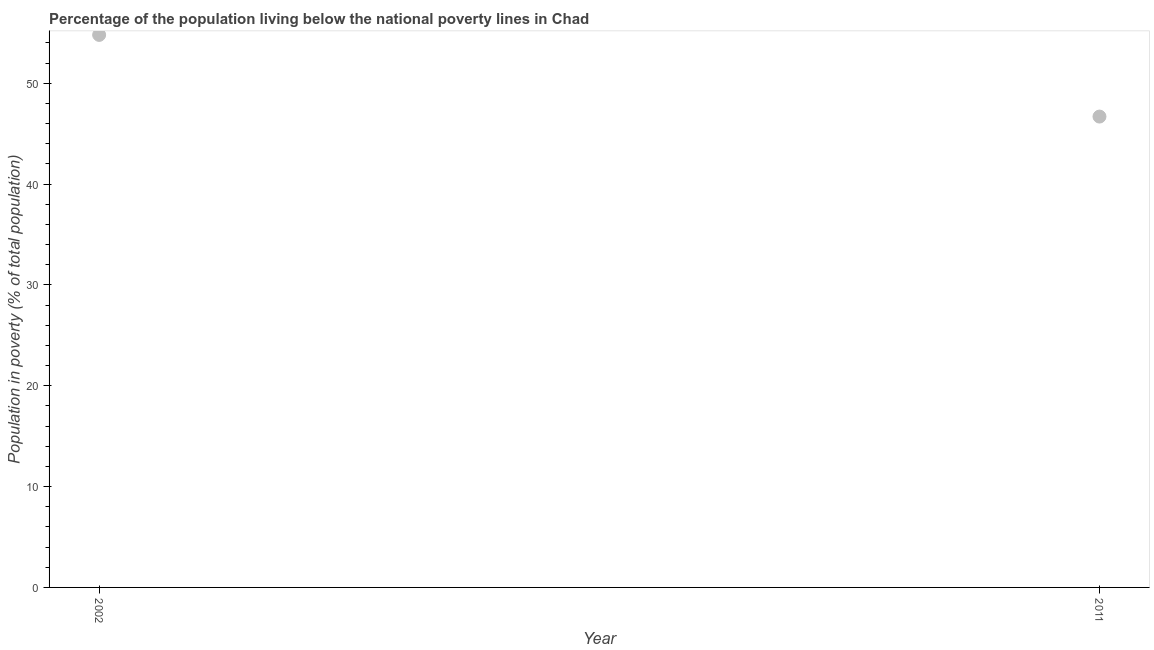What is the percentage of population living below poverty line in 2011?
Offer a very short reply. 46.7. Across all years, what is the maximum percentage of population living below poverty line?
Provide a short and direct response. 54.8. Across all years, what is the minimum percentage of population living below poverty line?
Keep it short and to the point. 46.7. What is the sum of the percentage of population living below poverty line?
Keep it short and to the point. 101.5. What is the difference between the percentage of population living below poverty line in 2002 and 2011?
Offer a very short reply. 8.1. What is the average percentage of population living below poverty line per year?
Provide a short and direct response. 50.75. What is the median percentage of population living below poverty line?
Keep it short and to the point. 50.75. What is the ratio of the percentage of population living below poverty line in 2002 to that in 2011?
Your response must be concise. 1.17. In how many years, is the percentage of population living below poverty line greater than the average percentage of population living below poverty line taken over all years?
Your answer should be compact. 1. Does the percentage of population living below poverty line monotonically increase over the years?
Provide a short and direct response. No. What is the title of the graph?
Provide a succinct answer. Percentage of the population living below the national poverty lines in Chad. What is the label or title of the X-axis?
Your answer should be very brief. Year. What is the label or title of the Y-axis?
Ensure brevity in your answer.  Population in poverty (% of total population). What is the Population in poverty (% of total population) in 2002?
Provide a succinct answer. 54.8. What is the Population in poverty (% of total population) in 2011?
Give a very brief answer. 46.7. What is the ratio of the Population in poverty (% of total population) in 2002 to that in 2011?
Give a very brief answer. 1.17. 